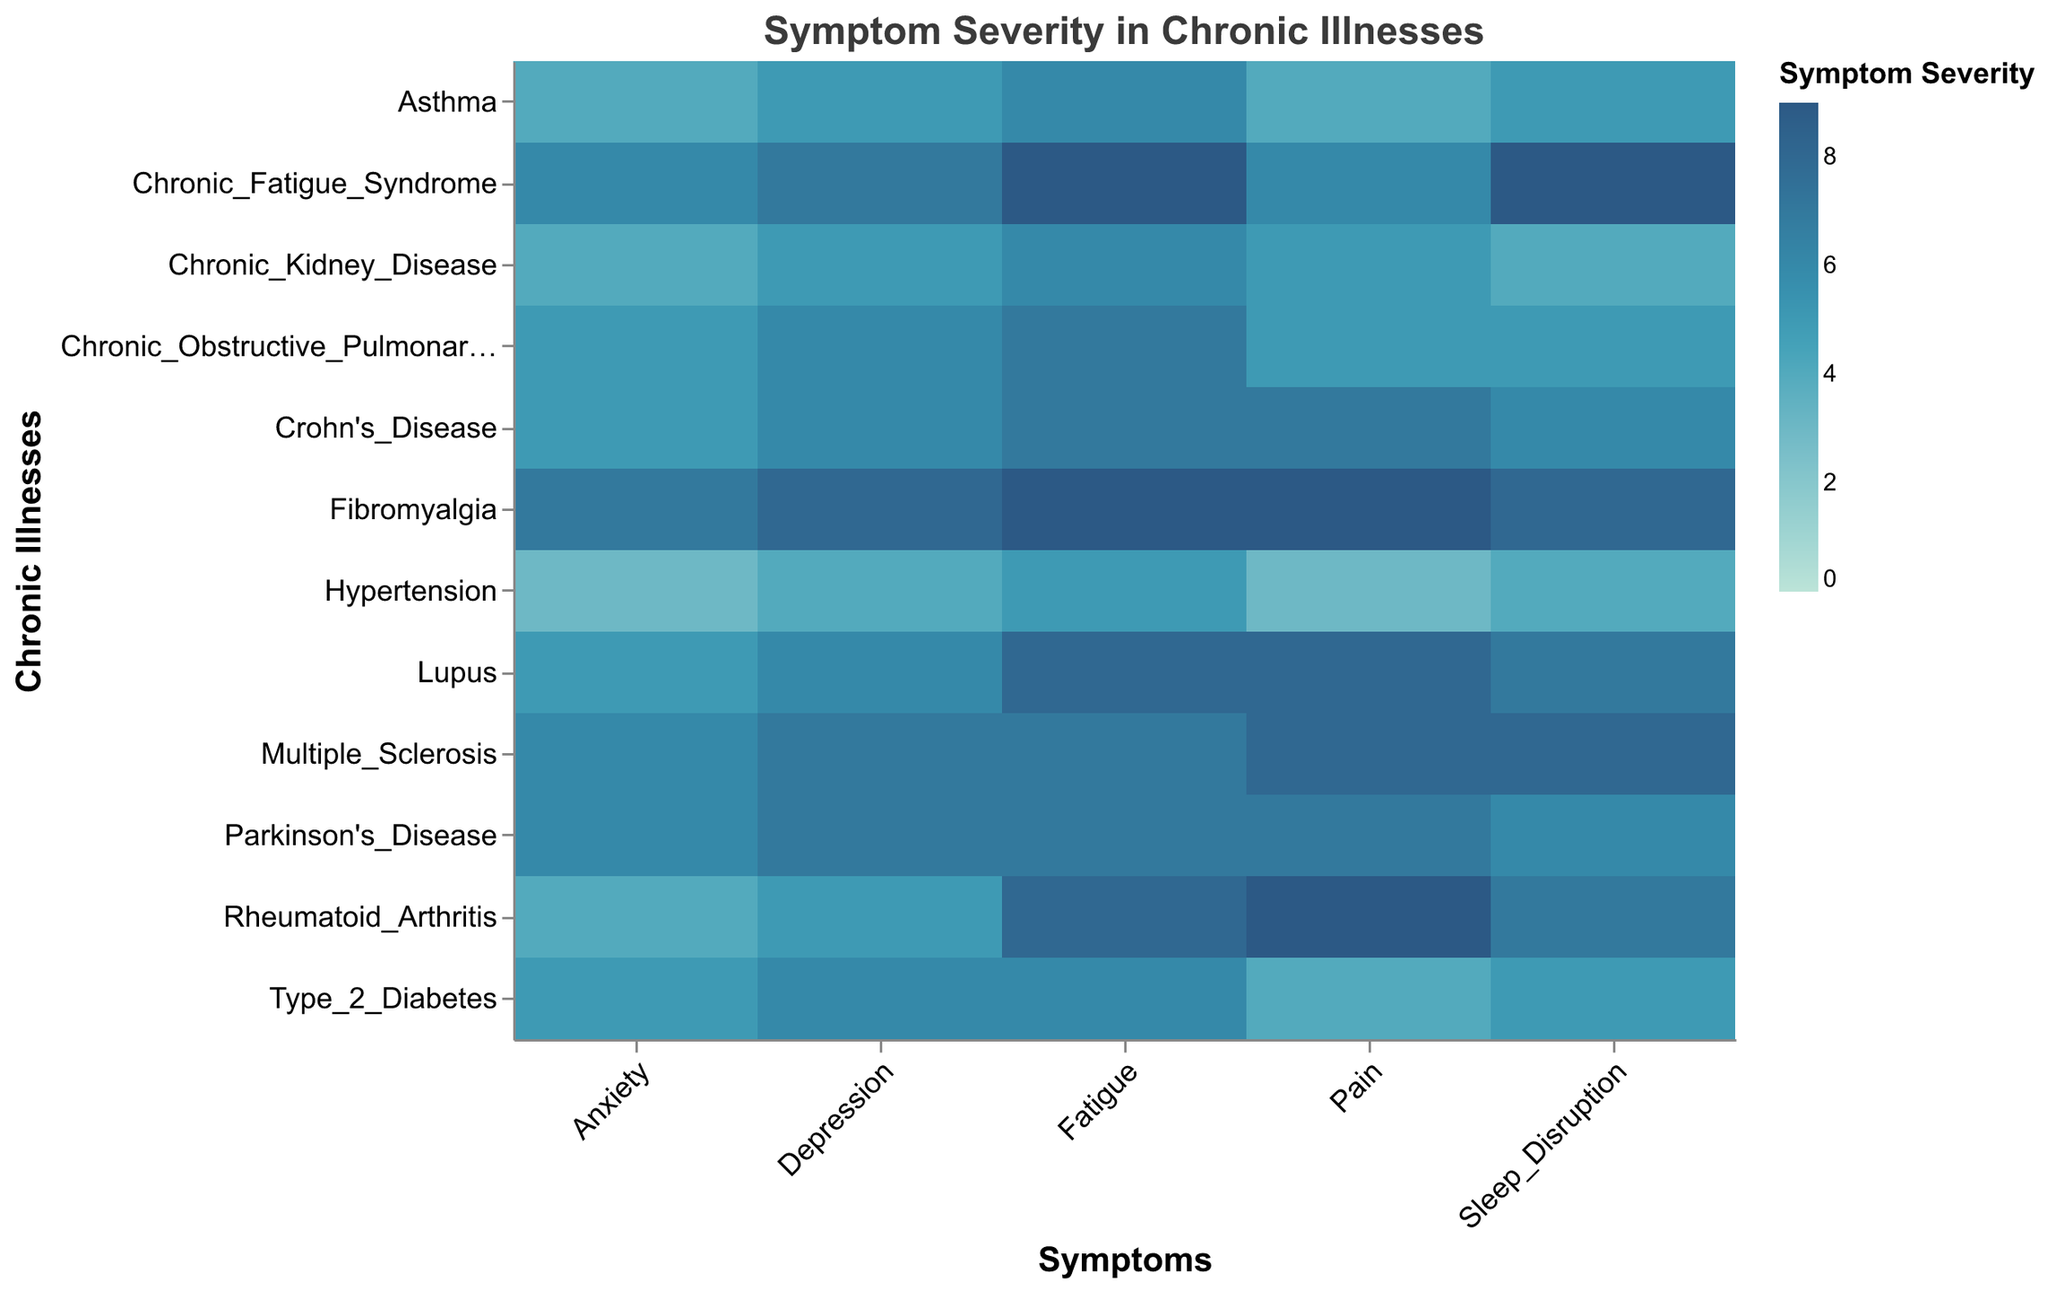What is the title of the heatmap? The title is located at the top of the figure and provides a concise description of the visualization's main focus.
Answer: Symptom Severity in Chronic Illnesses Which chronic illness has the highest severity for pain? Look for the cell with the highest color intensity (indicating the maximum severity) under the "Pain" symptom column. The shade with the highest intensity for "Pain" corresponds to Fibromyalgia and Rheumatoid Arthritis.
Answer: Fibromyalgia and Rheumatoid Arthritis What is the severity level of fatigue for Chronic Fatigue Syndrome? Locate the row for Chronic Fatigue Syndrome and find the color intensity under the "Fatigue" column. The color intensity represents the severity, which can be mapped back to the severity legend.
Answer: 9 Which symptom has the lowest severity for Hypertension? Locate the row for Hypertension and then compare the color intensities across all symptoms. The least intense color represents the lowest severity. Anxiety has a color intensity that maps to the lowest severity.
Answer: Anxiety Compare the severity of depression between Multiple Sclerosis and Chronic Obstructive Pulmonary Disease. Which illness shows higher severity for depression? Locate the rows for Multiple Sclerosis and Chronic Obstructive Pulmonary Disease. Compare the color intensity in the "Depression" column for both rows. The row with a more intense color indicates higher severity. Multiple Sclerosis has a more intense color.
Answer: Multiple Sclerosis What is the average severity of sleep disruption across all chronic illnesses? Sum all severity values for sleep disruption and divide by the number of illnesses. Severity values for sleep disruption are: 7, 5, 8, 9, 8, 6, 4, 5, 7, 4, 5, 6. Adding these gives 74, and dividing by 12 gives 6.17.
Answer: 6.17 Is there any symptom that is consistently severe (e.g., 7 or higher) across most chronic illnesses? Review the severity levels for each symptom across all chronic illnesses. Fatigue has values of 8, 6, 7, 9, 9, 7, 6, 7, 8, 5,6, and 7, showing high values for most cases.
Answer: Fatigue Which chronic illness has the most uniform severity across all symptoms? Determine which row shows the least variation in color intensity compared to others. Chronic Kidney Disease has severity values of 6, 5, 4, 5, and 4, which are relatively uniform.
Answer: Chronic Kidney Disease Identify the chronic illness with the most diverse symptom severity (highest range between minimum and maximum severity). Calculate the range (max - min) for each row to find the illness with the widest variation in severity. Rheumatoid Arthritis has a range of 9 - 4 = 5, which is one of the highest ranges.
Answer: Rheumatoid Arthritis 